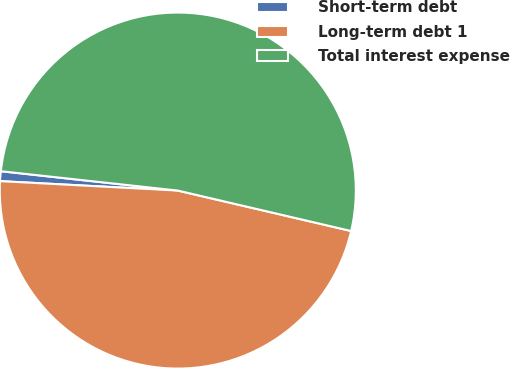<chart> <loc_0><loc_0><loc_500><loc_500><pie_chart><fcel>Short-term debt<fcel>Long-term debt 1<fcel>Total interest expense<nl><fcel>0.89%<fcel>47.2%<fcel>51.92%<nl></chart> 